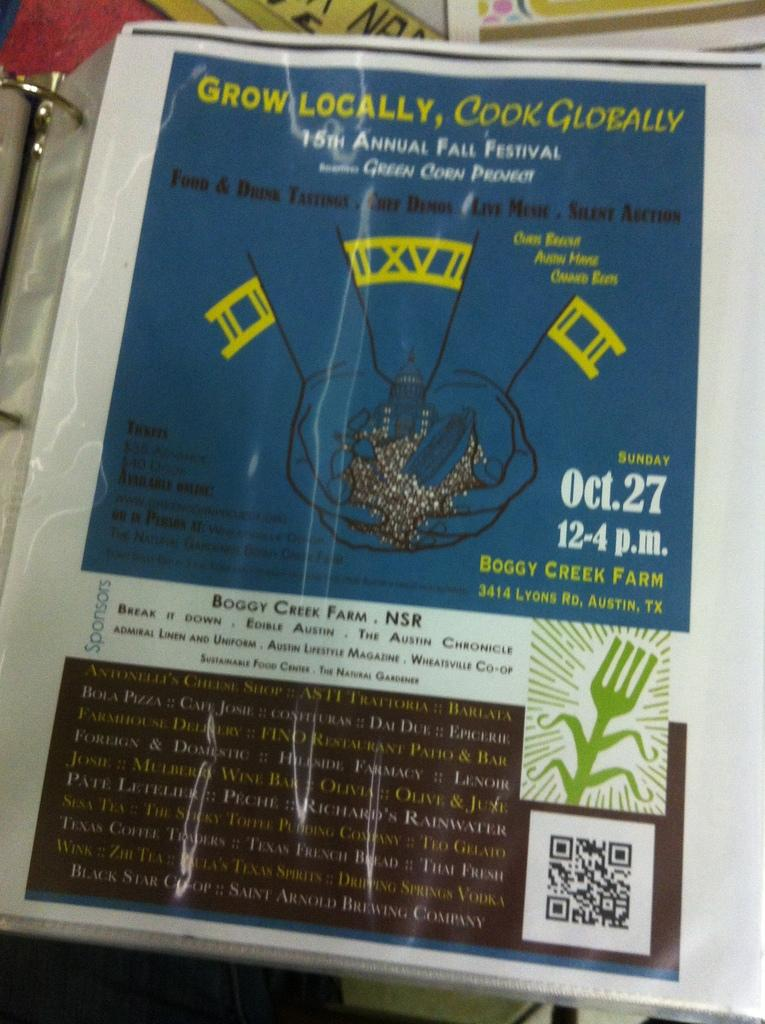<image>
Provide a brief description of the given image. A folder with a paper that is titled Grow Locally, Cook Globally and an picture of hands holding food 